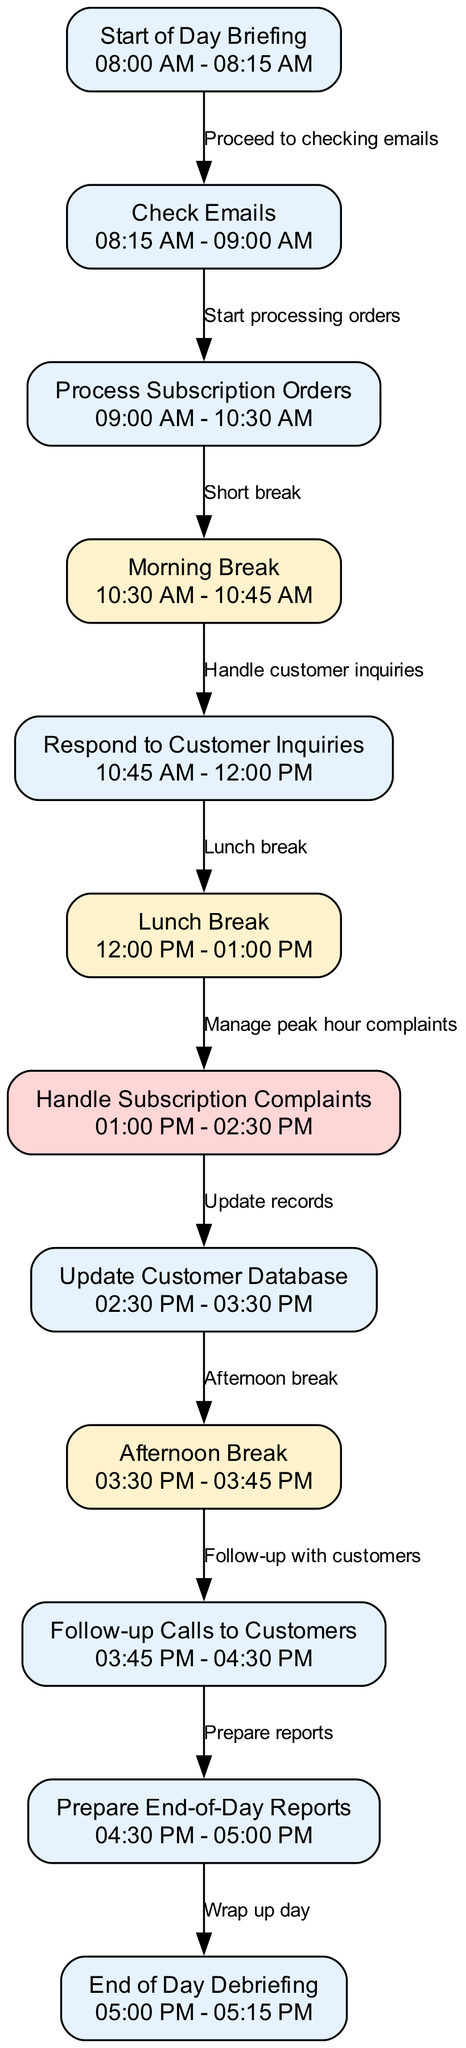What time does the "Respond to Customer Inquiries" task take place? The task "Respond to Customer Inquiries" is listed in the diagram and shows a time slot of "10:45 AM - 12:00 PM".
Answer: 10:45 AM - 12:00 PM Which task comes immediately after the "Morning Break"? The diagram indicates that after the "Morning Break", which occurs from "10:30 AM - 10:45 AM", the next task is "Respond to Customer Inquiries".
Answer: Respond to Customer Inquiries How many tasks are scheduled before lunch? By reviewing the diagram, we can see that the tasks prior to lunch include "Start of Day Briefing", "Check Emails", "Process Subscription Orders", "Morning Break", and "Respond to Customer Inquiries", totaling five tasks.
Answer: 5 What is the peak hour task in this schedule? The diagram highlights that the task titled "Handle Subscription Complaints" is indicated as a peak hour task, suggesting it is a busy period.
Answer: Handle Subscription Complaints What is the time for the "Afternoon Break"? According to the diagram, the "Afternoon Break" occurs from "03:30 PM - 03:45 PM".
Answer: 03:30 PM - 03:45 PM What task directly follows "Follow-up Calls to Customers"? The diagram illustrates that after "Follow-up Calls to Customers", which occurs from "03:45 PM - 04:30 PM", the next task is "Prepare End-of-Day Reports".
Answer: Prepare End-of-Day Reports How many breaks are included in the daily schedule? By examining the diagram, we observe three breaks: "Morning Break", "Lunch Break", and "Afternoon Break".
Answer: 3 What are the total number of nodes in this diagram? Counting all the tasks and breaks listed in the diagram, we find there are a total of twelve nodes present.
Answer: 12 What does the edge labeled "Manage peak hour complaints" connect? The edge labeled "Manage peak hour complaints" connects the "Lunch Break" node to the "Handle Subscription Complaints" node in the diagram, indicating the flow from the break to the handling of peak complaints.
Answer: Lunch Break to Handle Subscription Complaints 